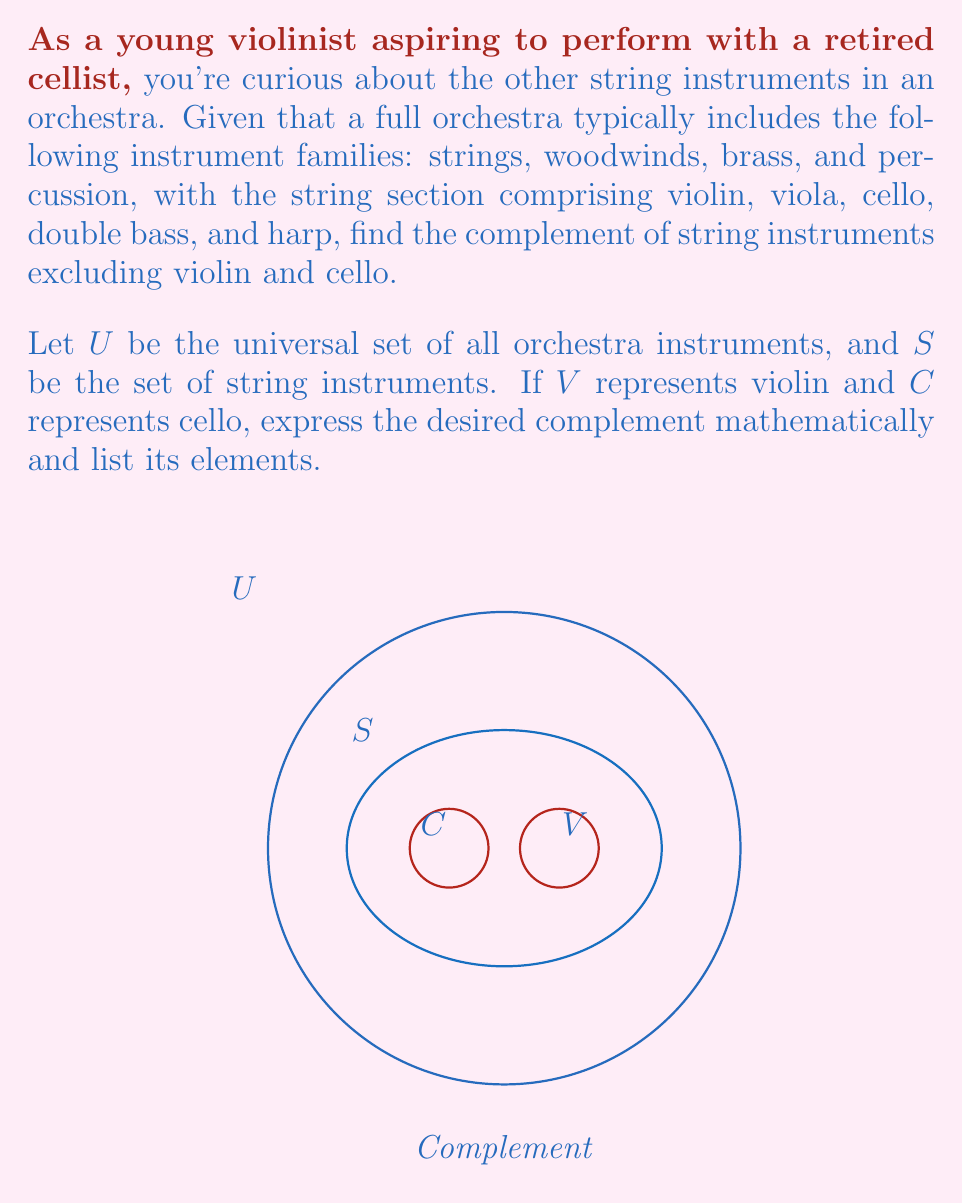Can you answer this question? To solve this problem, let's follow these steps:

1) First, we need to identify the set of all string instruments ($S$):
   $S = \{\text{violin, viola, cello, double bass, harp}\}$

2) We're asked to exclude violin ($V$) and cello ($C$) from this set:
   $S - \{V, C\} = \{\text{viola, double bass, harp}\}$

3) The complement of this set within the universal set $U$ (all orchestra instruments) is what we're looking for. In set theory, this is denoted as:
   $(S - \{V, C\})^c$ or $U - (S - \{V, C\})$

4) This complement will include all non-string instruments, plus the violin and cello:
   $(S - \{V, C\})^c = \{\text{all woodwinds, all brass, all percussion, violin, cello}\}$

5) To list the elements more specifically:
   $(S - \{V, C\})^c = \{\text{flute, oboe, clarinet, bassoon, trumpet, horn, trombone, tuba, timpani, cymbals, triangle, snare drum, bass drum, violin, cello}\}$

Note: This list is not exhaustive and may vary slightly depending on the specific orchestra composition.
Answer: $(S - \{V, C\})^c = \{\text{woodwinds, brass, percussion, violin, cello}\}$ 